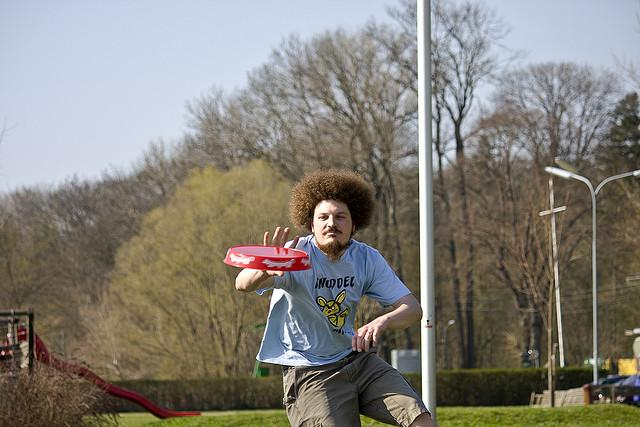What can be played on here? frisbee 